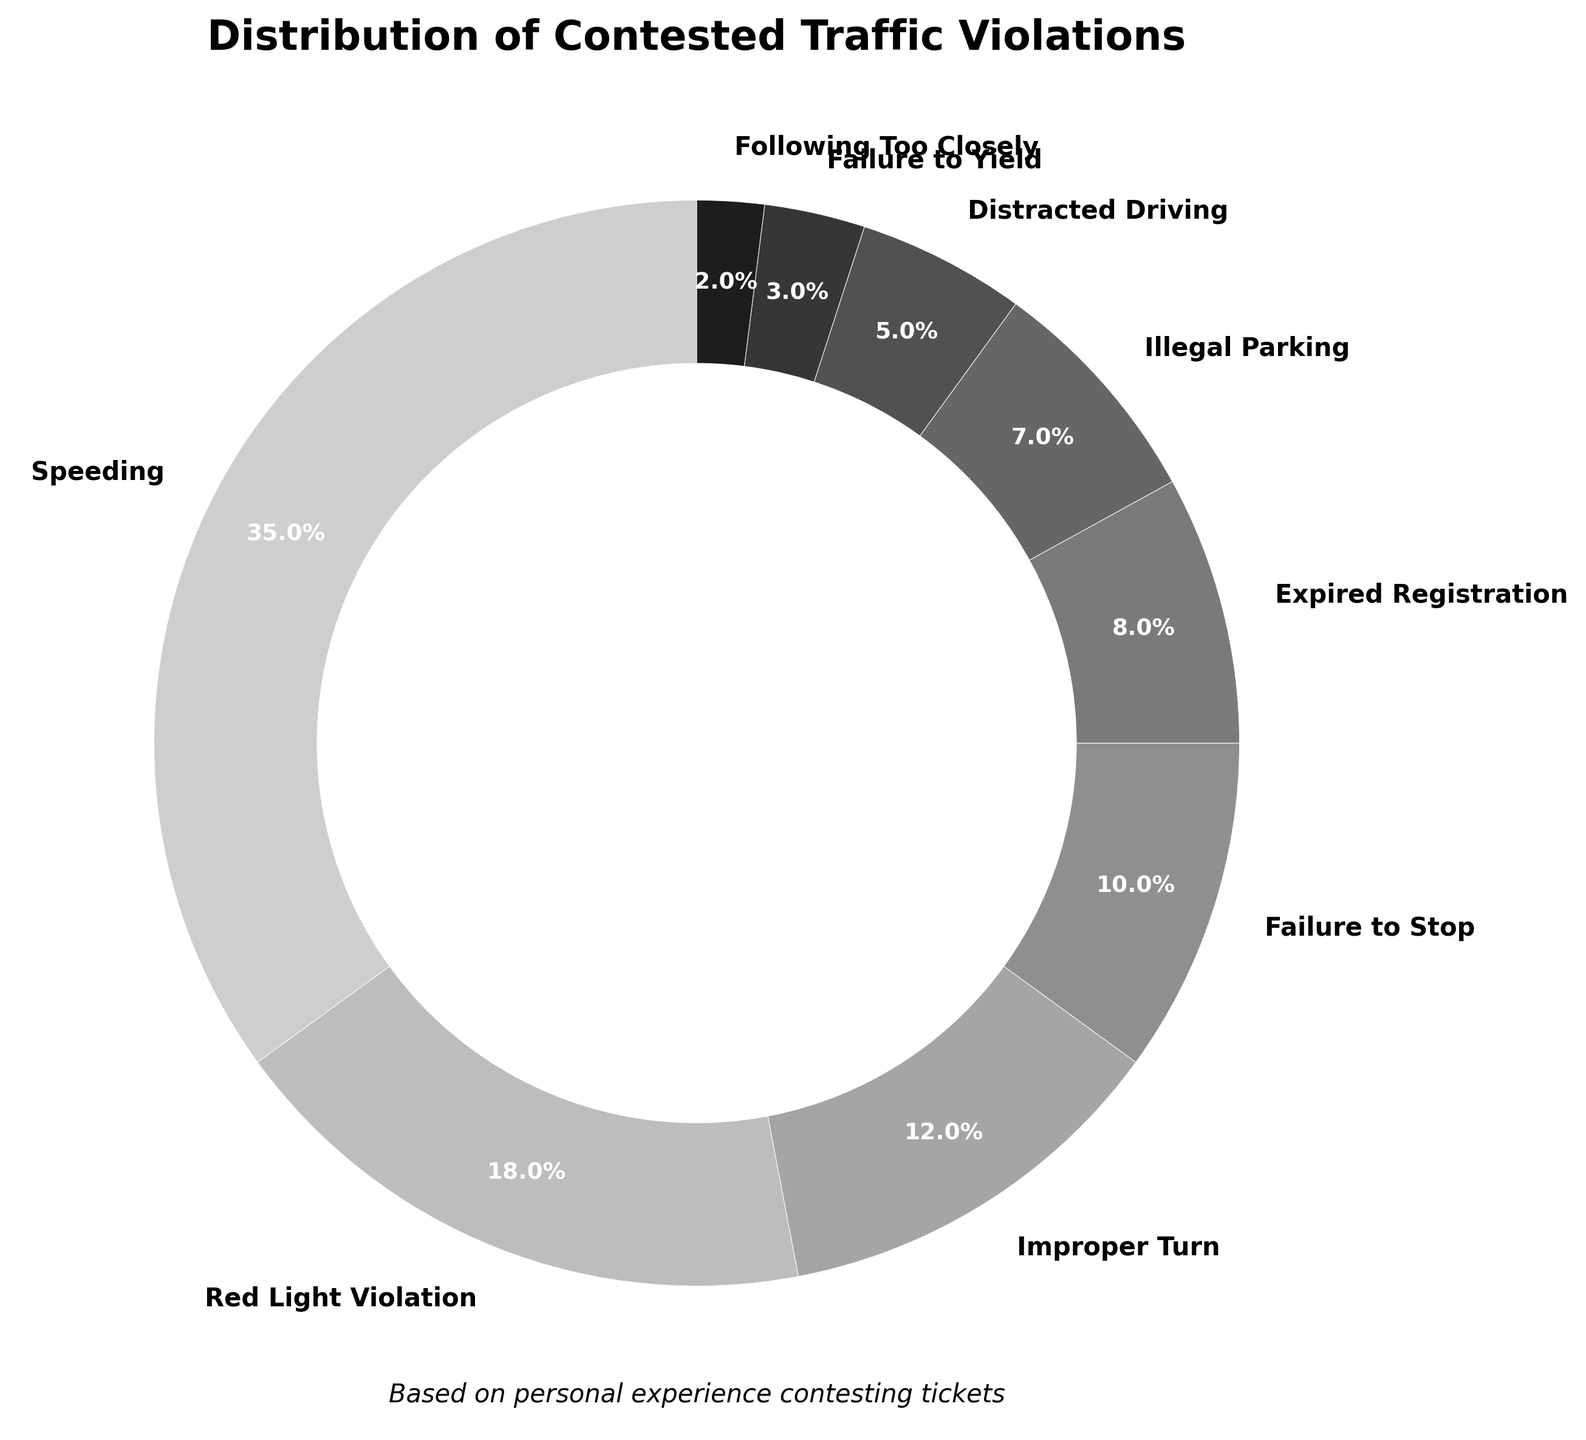Which type of violation has the highest percentage? The figure shows that speeding has the largest section of the pie chart. The color and label indicate it has the highest percentage.
Answer: Speeding What is the combined percentage of Red Light Violation and Distracted Driving? We need to add the percentages of Red Light Violation (18%) and Distracted Driving (5%). 18 + 5 = 23.
Answer: 23% Which violation is the least common among contested tickets? The pie chart shows that Following Too Closely has the smallest section, labeled with 2%.
Answer: Following Too Closely Are Expired Registration violations more or less frequent than Improper Turn violations? The figure shows Expired Registration at 8% and Improper Turn at 12%, indicating Expired Registration is less frequent.
Answer: Less frequent What percentage of violations is attributable to illegal parking and failure to yield combined? Sum the percentages for Illegal Parking (7%) and Failure to Yield (3%). 7 + 3 = 10.
Answer: 10% How much more frequent are Speeding violations compared to Failure to Stop violations? Subtract the percentage of Failure to Stop (10%) from Speeding (35%). 35 - 10 = 25.
Answer: 25% Which categories together make up more than half of all violations? We add the percentages starting from the largest category until it exceeds 50%. Speeding (35%) + Red Light Violation (18%) = 53%.
Answer: Speeding and Red Light Violation What is the average percentage of Improper Turn, Expired Registration, and Illegal Parking violations? Calculate the average of the three percentages: (12 + 8 + 7) / 3 = 27 / 3 = 9.
Answer: 9% By how much does the percentage of Speeding violations exceed the combined percentage of following too closely and failure to yield? First, sum the percentages for Following Too Closely (2%) and Failure to Yield (3%). Then subtract this sum from the Speeding percentage: 35 - (2 + 3) = 30.
Answer: 30% 